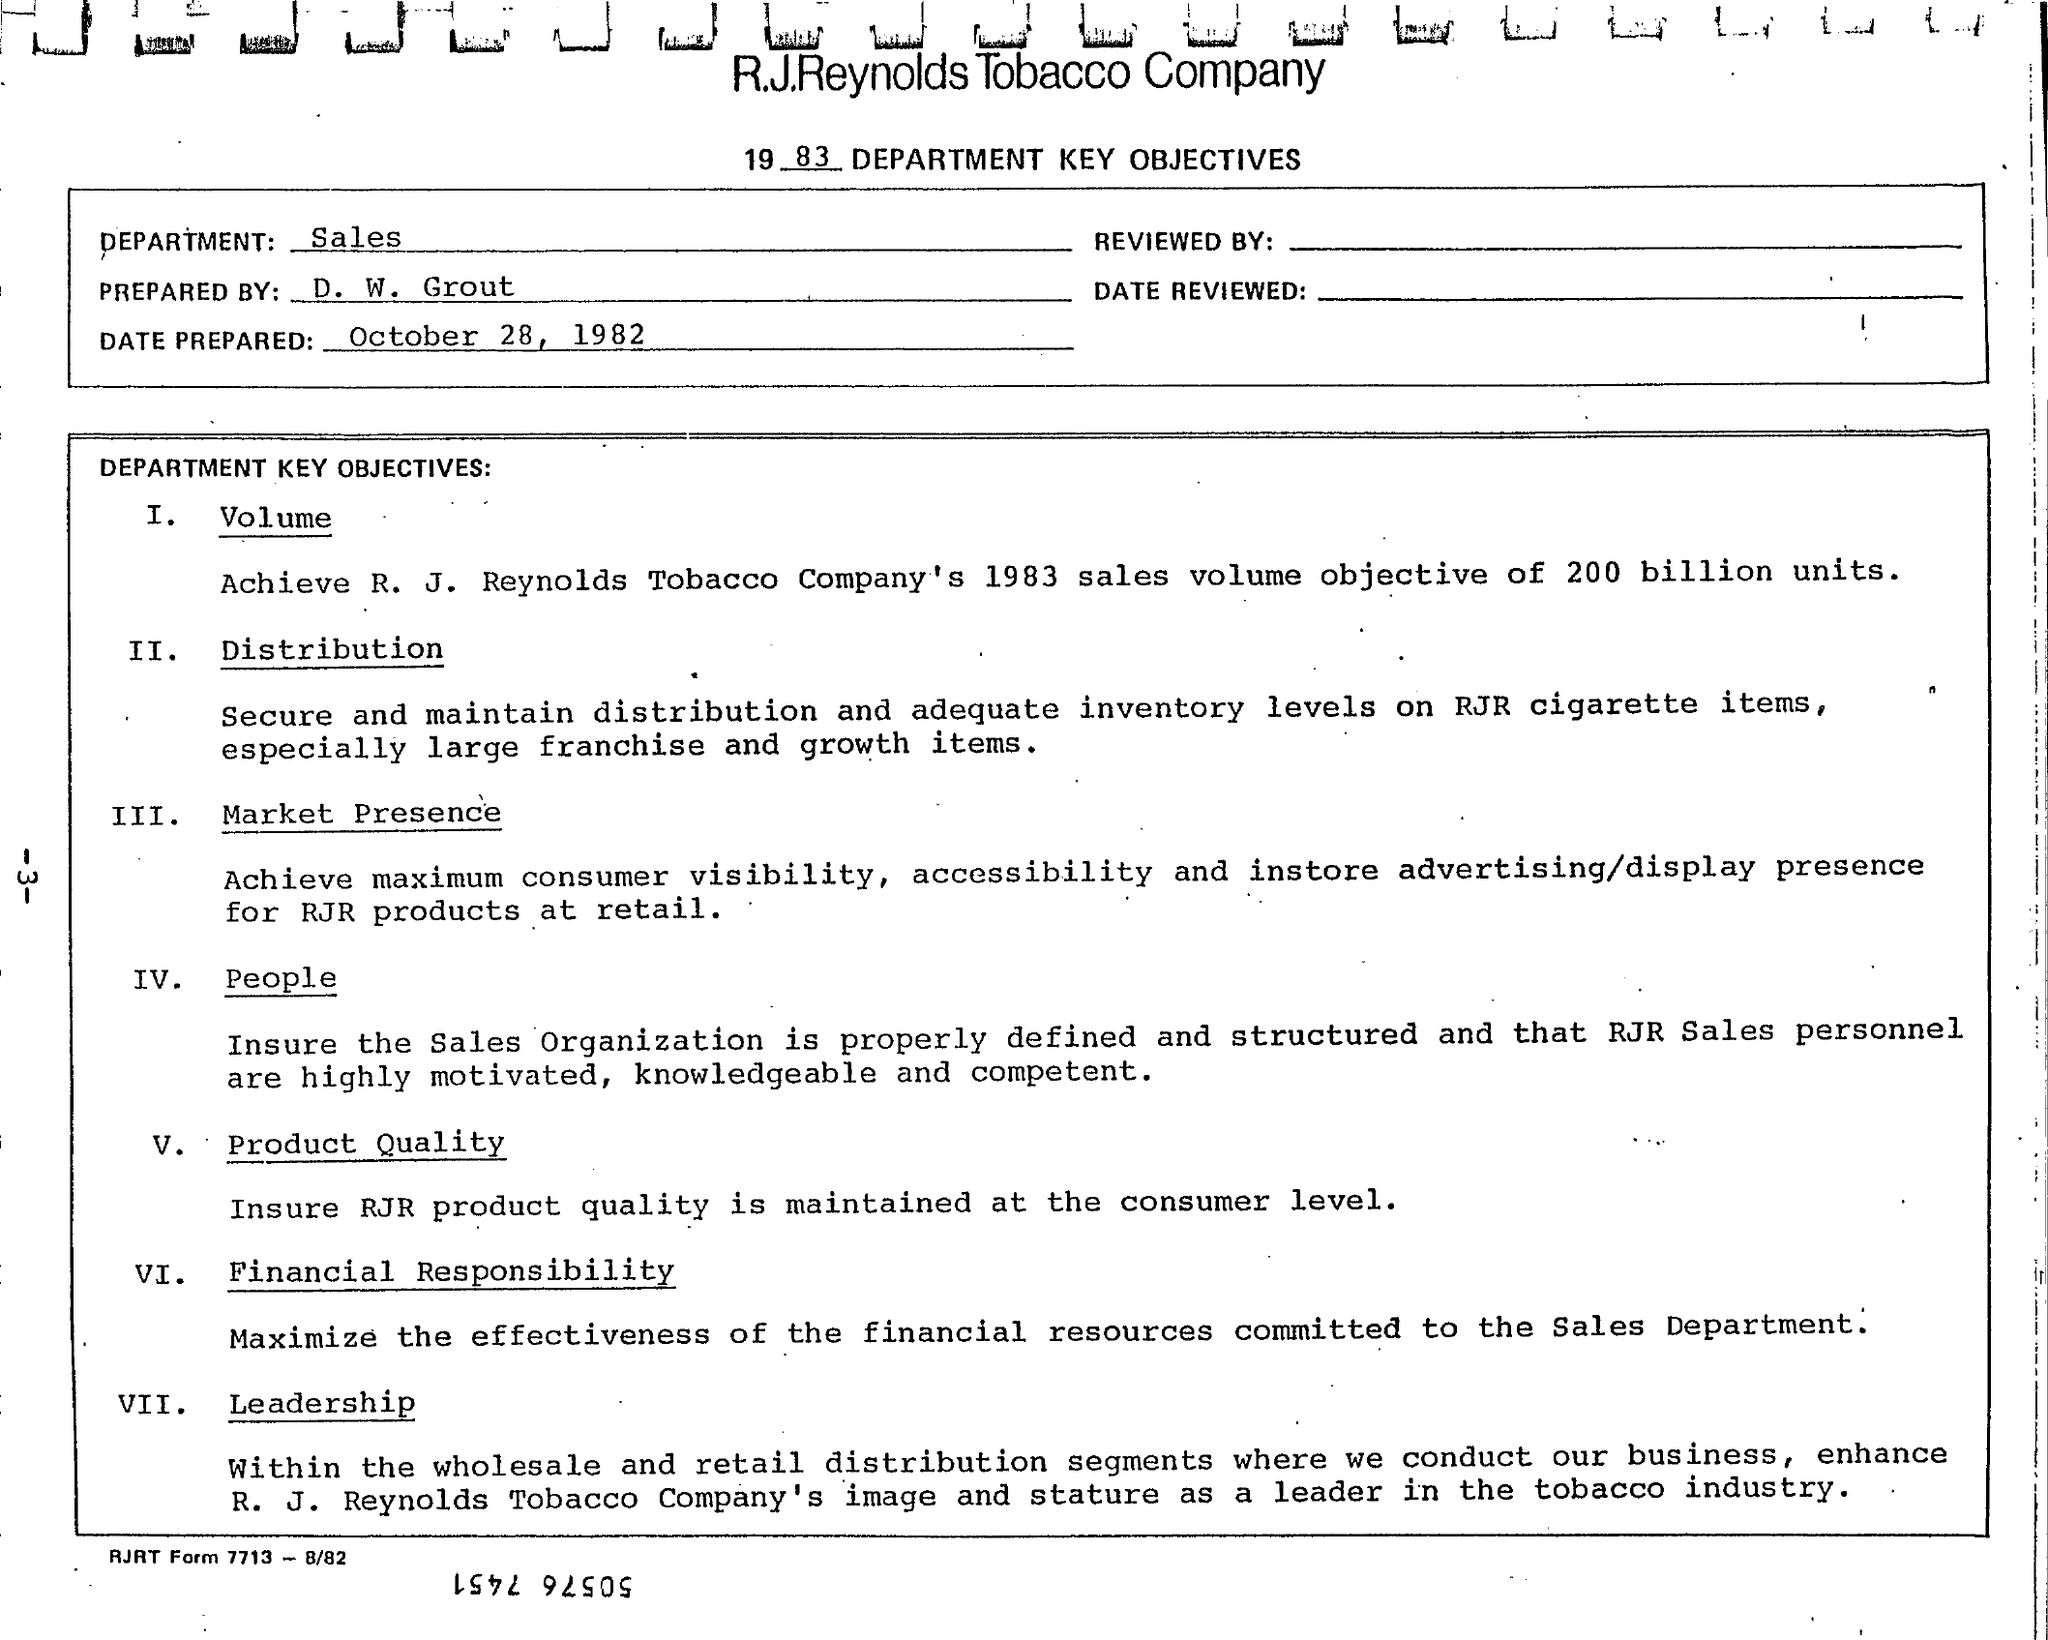Which is the Department?
Keep it short and to the point. Sales. Prepared by whom?
Provide a short and direct response. D. W. Grout. When is the Date Prepared?
Your answer should be compact. October 28, 1982. What is the Title of the document?
Make the answer very short. 1983 department Key Objectives. 